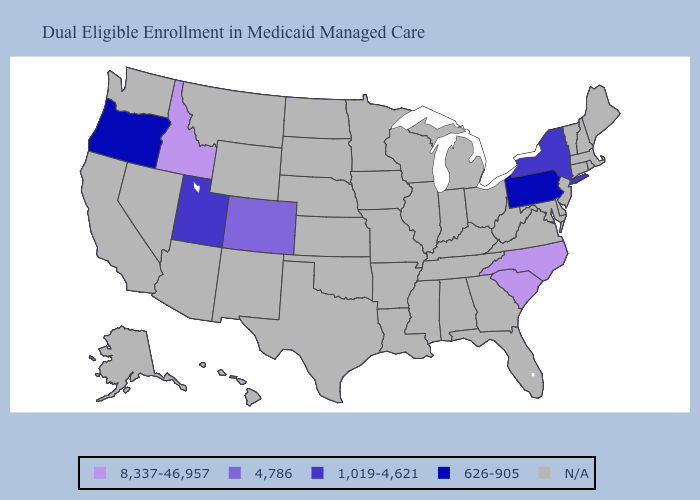What is the value of Arkansas?
Quick response, please. N/A. What is the lowest value in states that border Nebraska?
Concise answer only. 4,786. Is the legend a continuous bar?
Concise answer only. No. Name the states that have a value in the range 1,019-4,621?
Short answer required. New York, Utah. Does the first symbol in the legend represent the smallest category?
Answer briefly. No. Name the states that have a value in the range 626-905?
Concise answer only. Oregon, Pennsylvania. What is the lowest value in the USA?
Keep it brief. 626-905. Name the states that have a value in the range 8,337-46,957?
Concise answer only. Idaho, North Carolina, South Carolina. Name the states that have a value in the range 4,786?
Answer briefly. Colorado. Name the states that have a value in the range 8,337-46,957?
Write a very short answer. Idaho, North Carolina, South Carolina. What is the lowest value in states that border Colorado?
Short answer required. 1,019-4,621. 